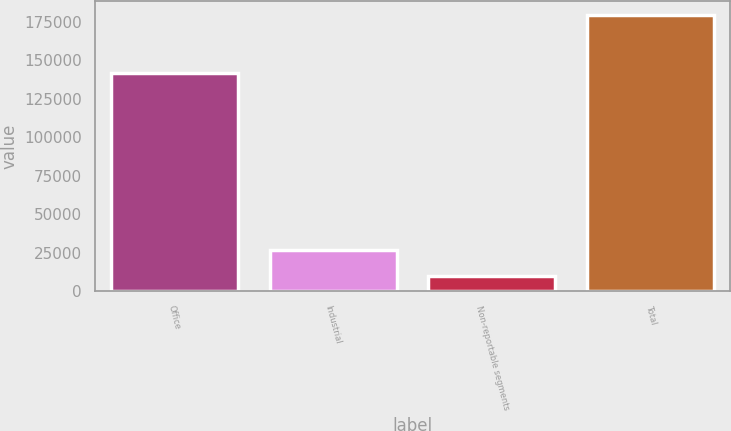<chart> <loc_0><loc_0><loc_500><loc_500><bar_chart><fcel>Office<fcel>Industrial<fcel>Non-reportable segments<fcel>Total<nl><fcel>141993<fcel>27154<fcel>10226<fcel>179373<nl></chart> 